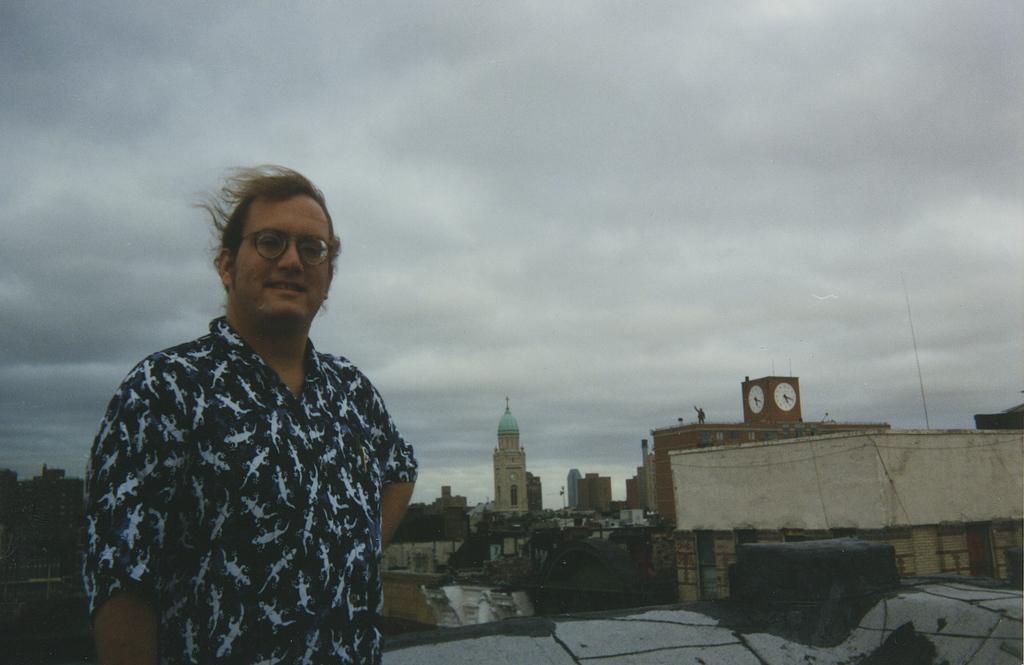Please provide a concise description of this image. In this image I can see a person wearing a black color shirt and his smiling and in the background I can see building and towers and at the top I can see the sky and I can see the clock visible in the middle and person wearing spectacle and the sky is cloudy 